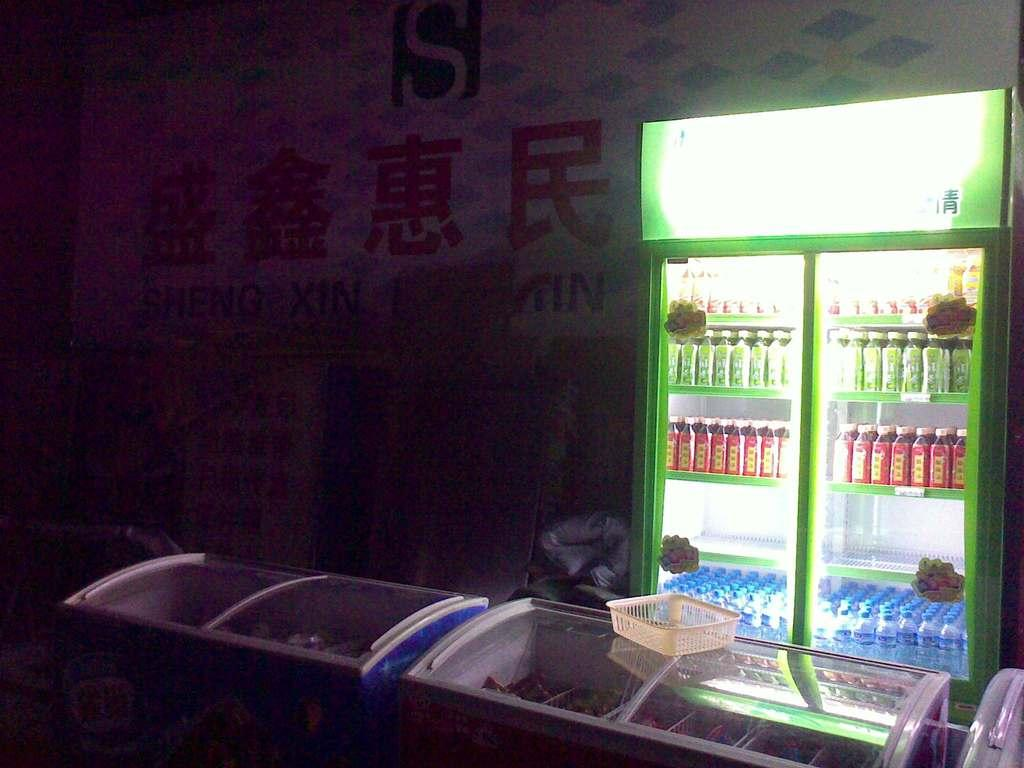<image>
Present a compact description of the photo's key features. a display of brightly colored bottles in a dark chinese shop with a sign that has the letters "IN" on it 